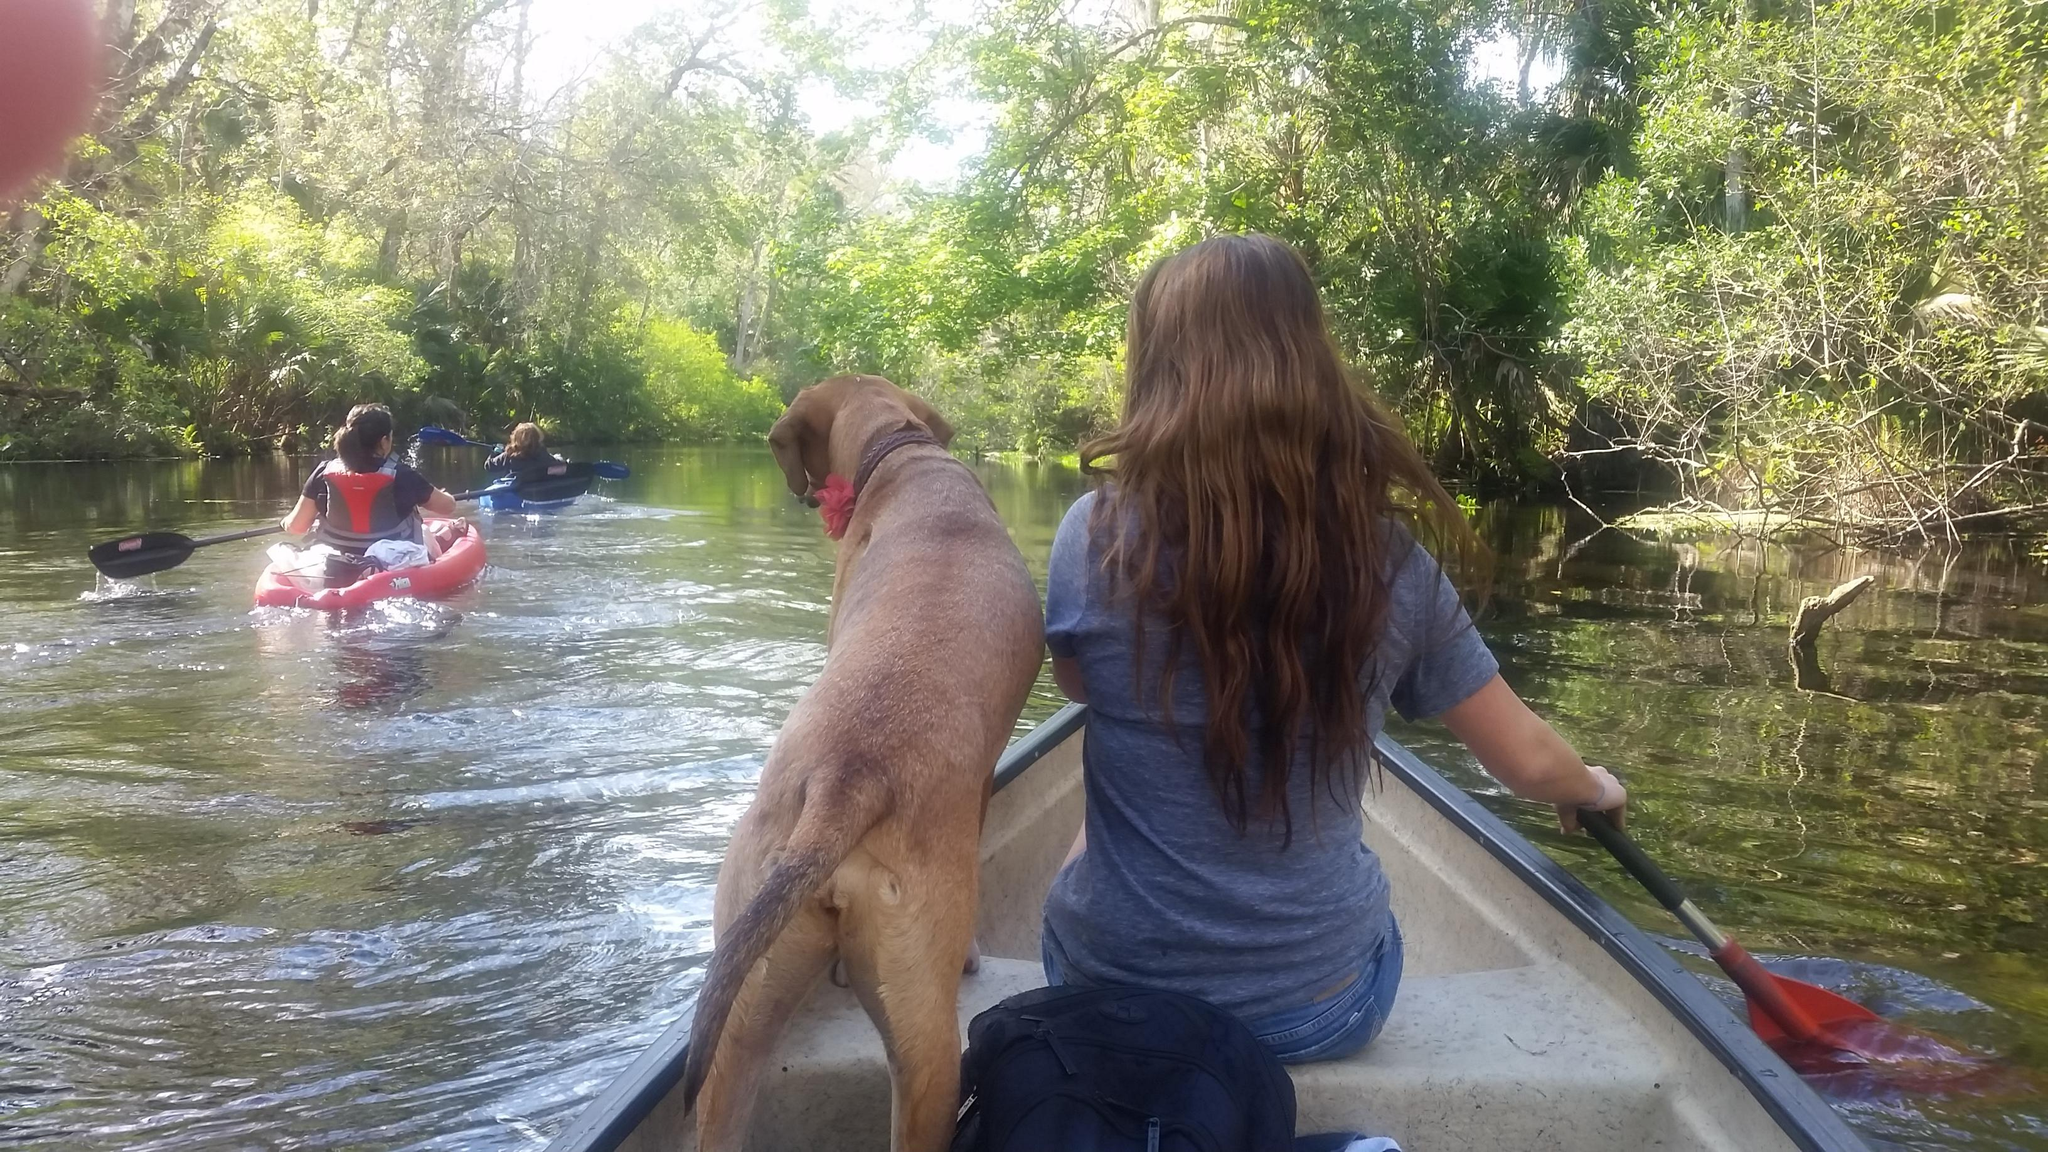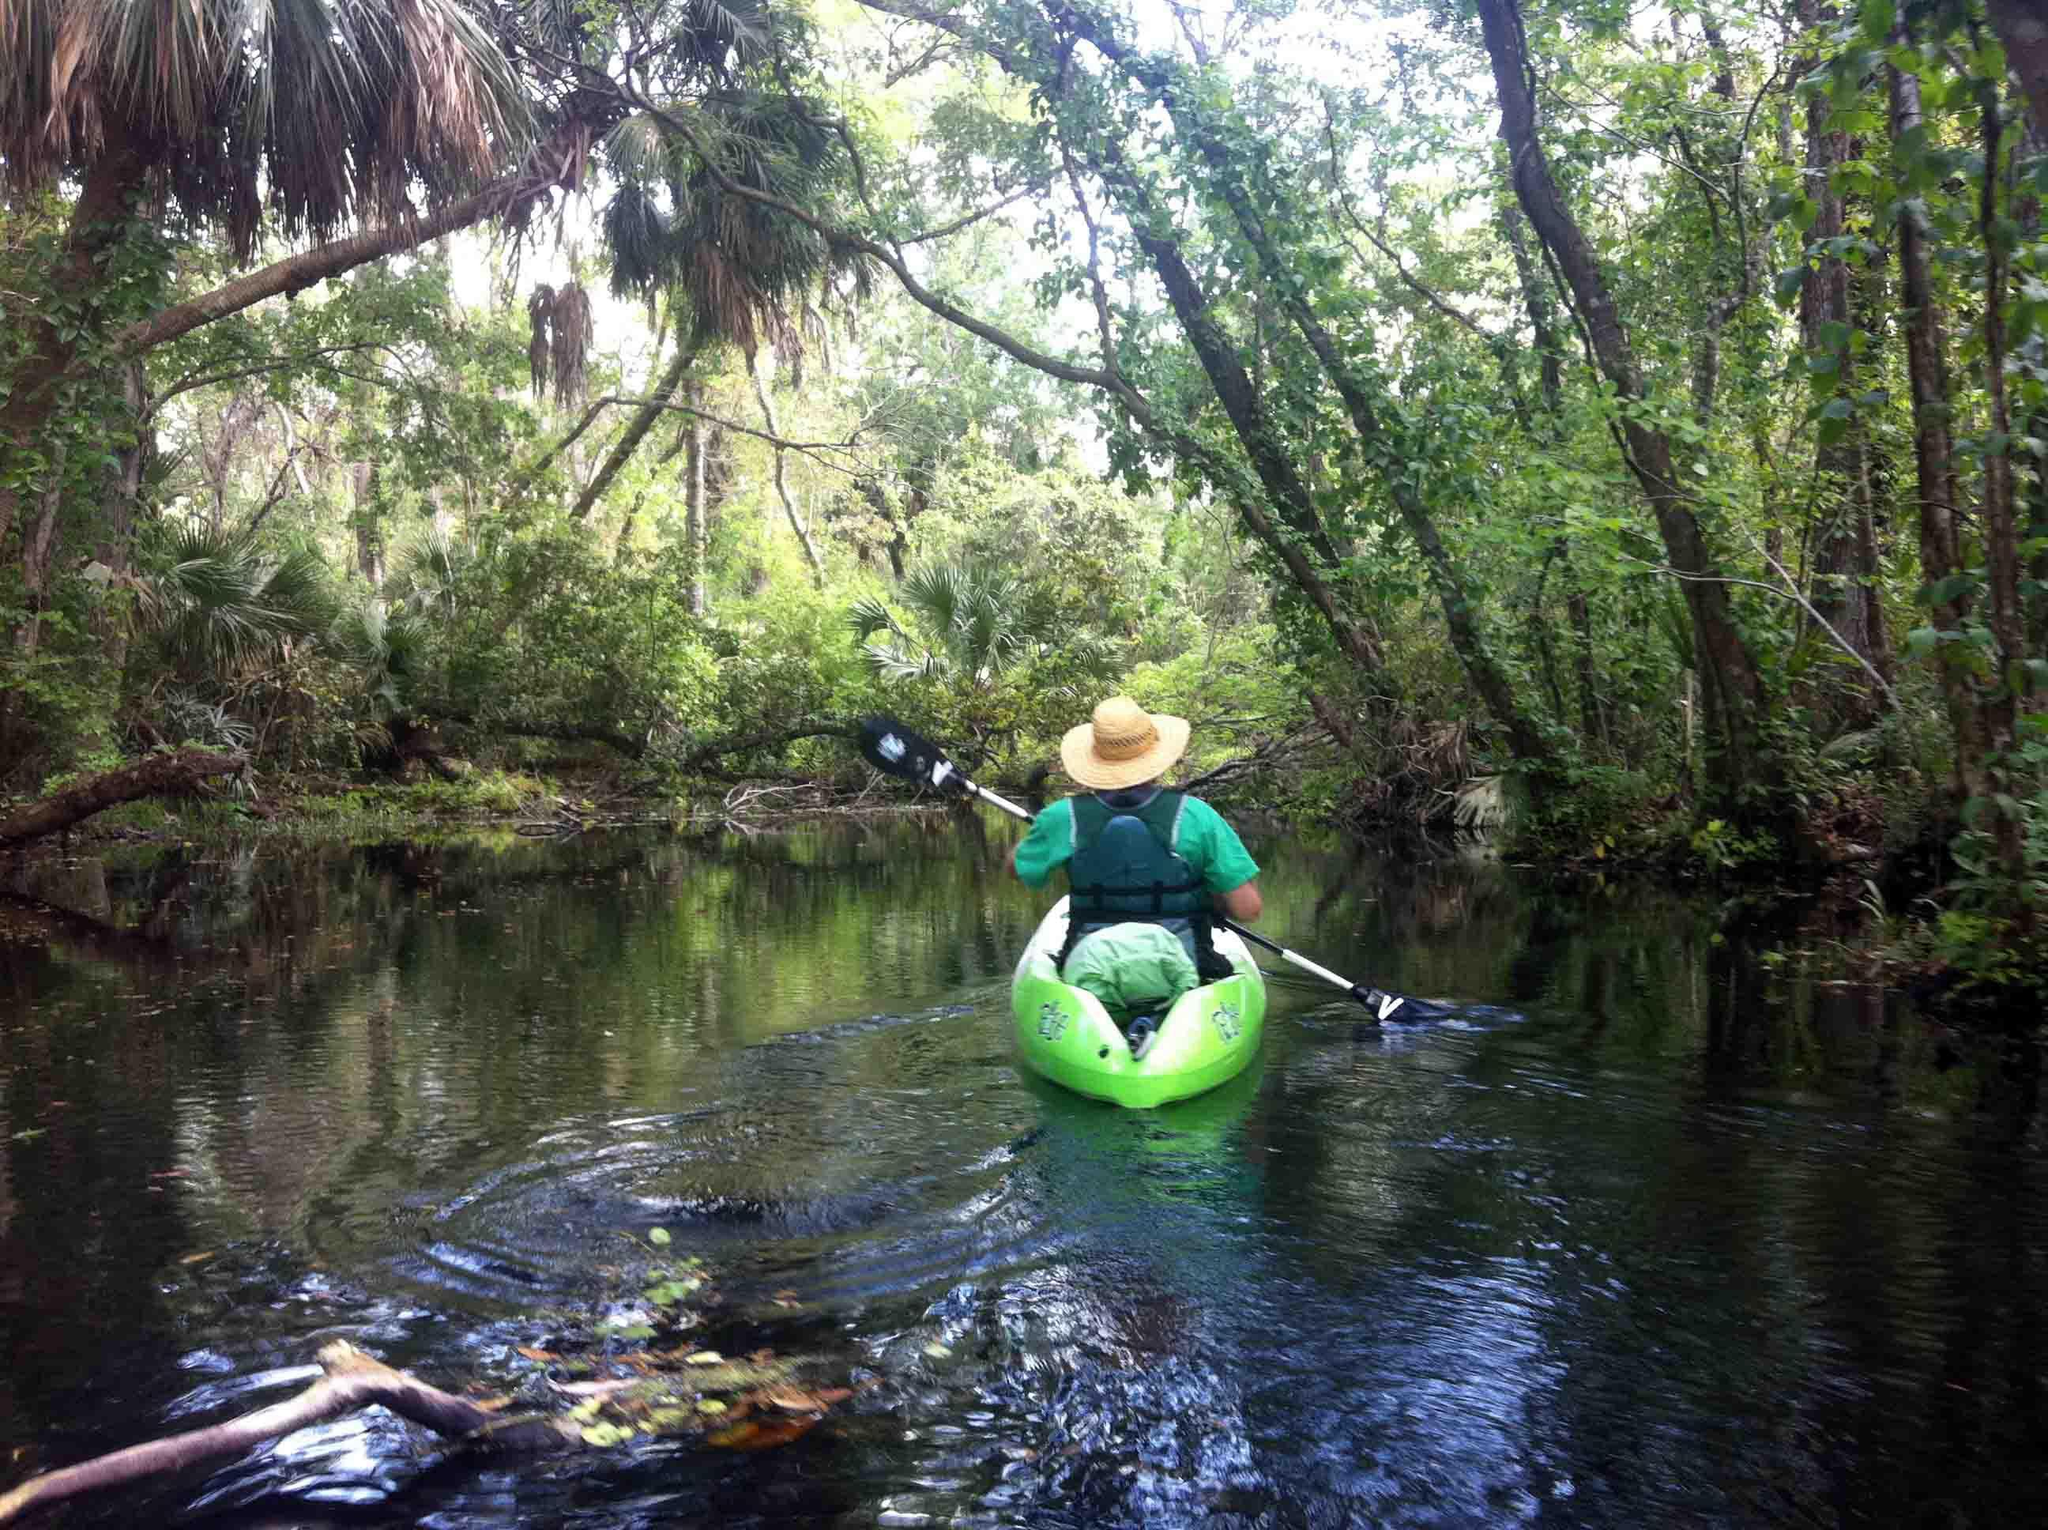The first image is the image on the left, the second image is the image on the right. Analyze the images presented: Is the assertion "There is no more than one human in the right image wearing a hat." valid? Answer yes or no. Yes. 